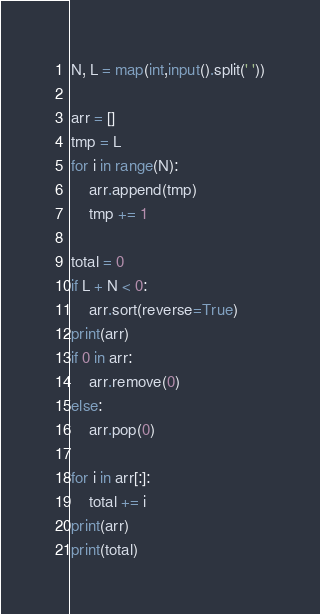Convert code to text. <code><loc_0><loc_0><loc_500><loc_500><_Python_>N, L = map(int,input().split(' '))

arr = []
tmp = L
for i in range(N):
    arr.append(tmp)
    tmp += 1

total = 0
if L + N < 0:
    arr.sort(reverse=True) 
print(arr)
if 0 in arr:
    arr.remove(0)
else:
    arr.pop(0)

for i in arr[:]:
    total += i
print(arr)
print(total)</code> 